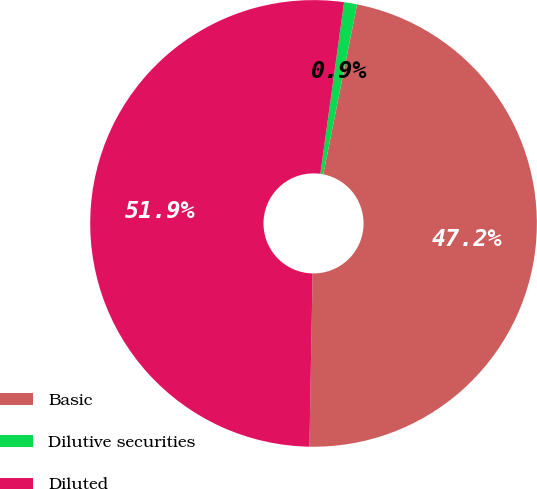<chart> <loc_0><loc_0><loc_500><loc_500><pie_chart><fcel>Basic<fcel>Dilutive securities<fcel>Diluted<nl><fcel>47.17%<fcel>0.94%<fcel>51.89%<nl></chart> 